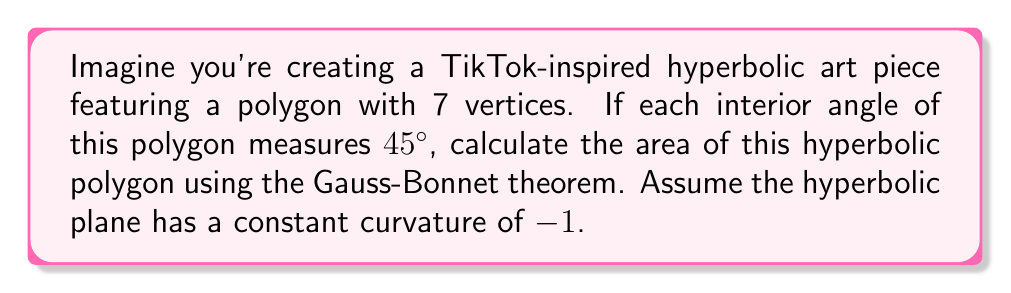Solve this math problem. Let's approach this step-by-step using the Gauss-Bonnet theorem:

1) The Gauss-Bonnet theorem for hyperbolic polygons states:

   $$A = (n-2)\pi - \sum_{i=1}^n \theta_i$$

   Where $A$ is the area, $n$ is the number of vertices, and $\theta_i$ are the interior angles.

2) We're given:
   - Number of vertices, $n = 7$
   - Each interior angle, $\theta = 45° = \frac{\pi}{4}$ radians

3) The sum of all interior angles:

   $$\sum_{i=1}^n \theta_i = 7 \cdot \frac{\pi}{4} = \frac{7\pi}{4}$$

4) Now, let's plug these into the Gauss-Bonnet formula:

   $$A = (7-2)\pi - \frac{7\pi}{4}$$

5) Simplify:

   $$A = 5\pi - \frac{7\pi}{4} = \frac{20\pi}{4} - \frac{7\pi}{4} = \frac{13\pi}{4}$$

Therefore, the area of the hyperbolic polygon is $\frac{13\pi}{4}$.
Answer: $\frac{13\pi}{4}$ 